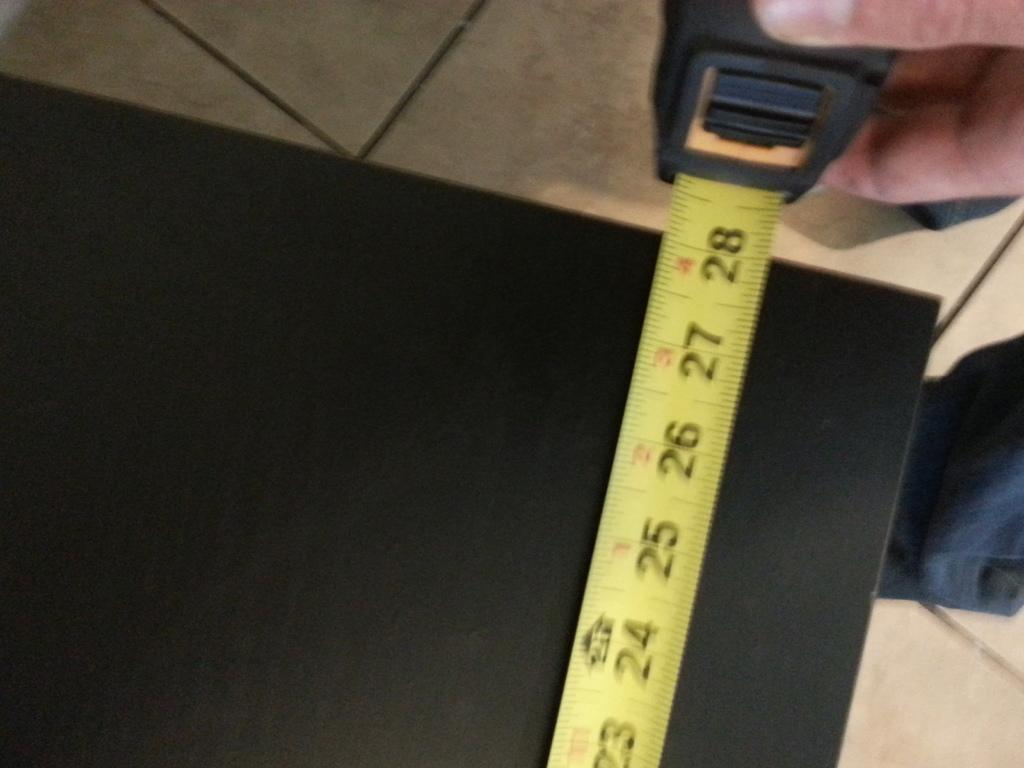<image>
Summarize the visual content of the image. A yellow measuring tape indicates that the black board measures 28 inches. 